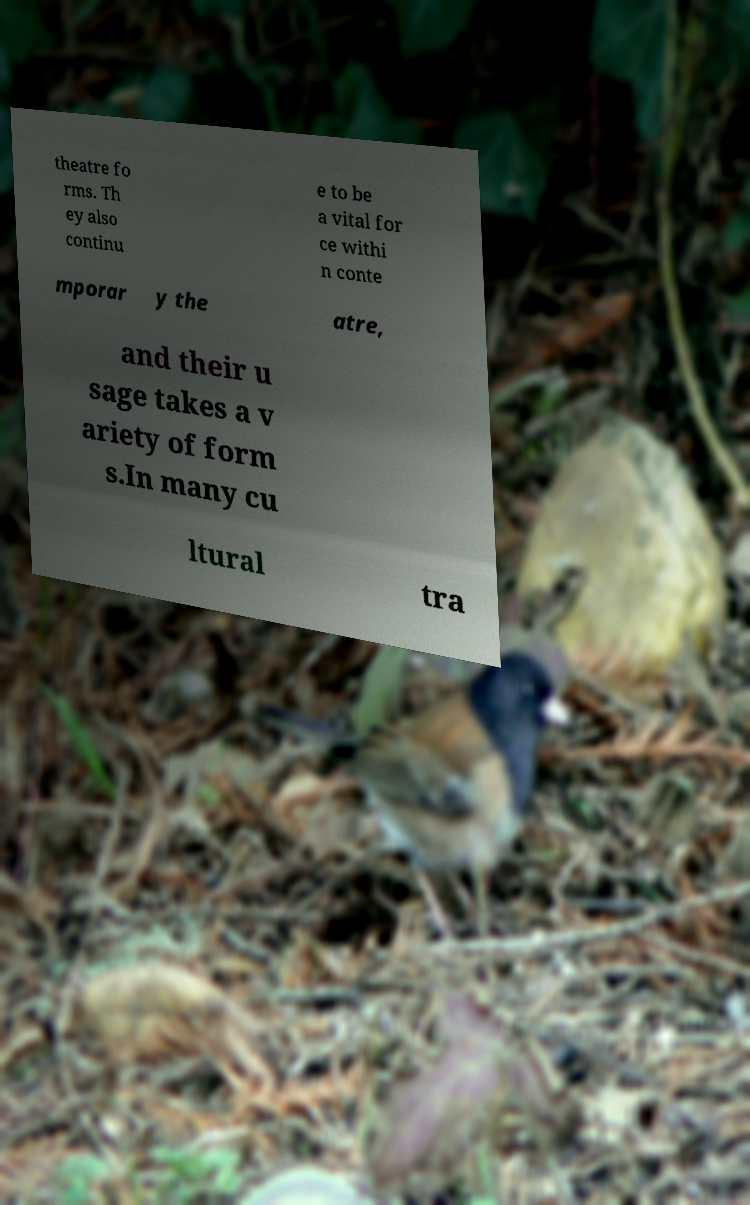There's text embedded in this image that I need extracted. Can you transcribe it verbatim? theatre fo rms. Th ey also continu e to be a vital for ce withi n conte mporar y the atre, and their u sage takes a v ariety of form s.In many cu ltural tra 